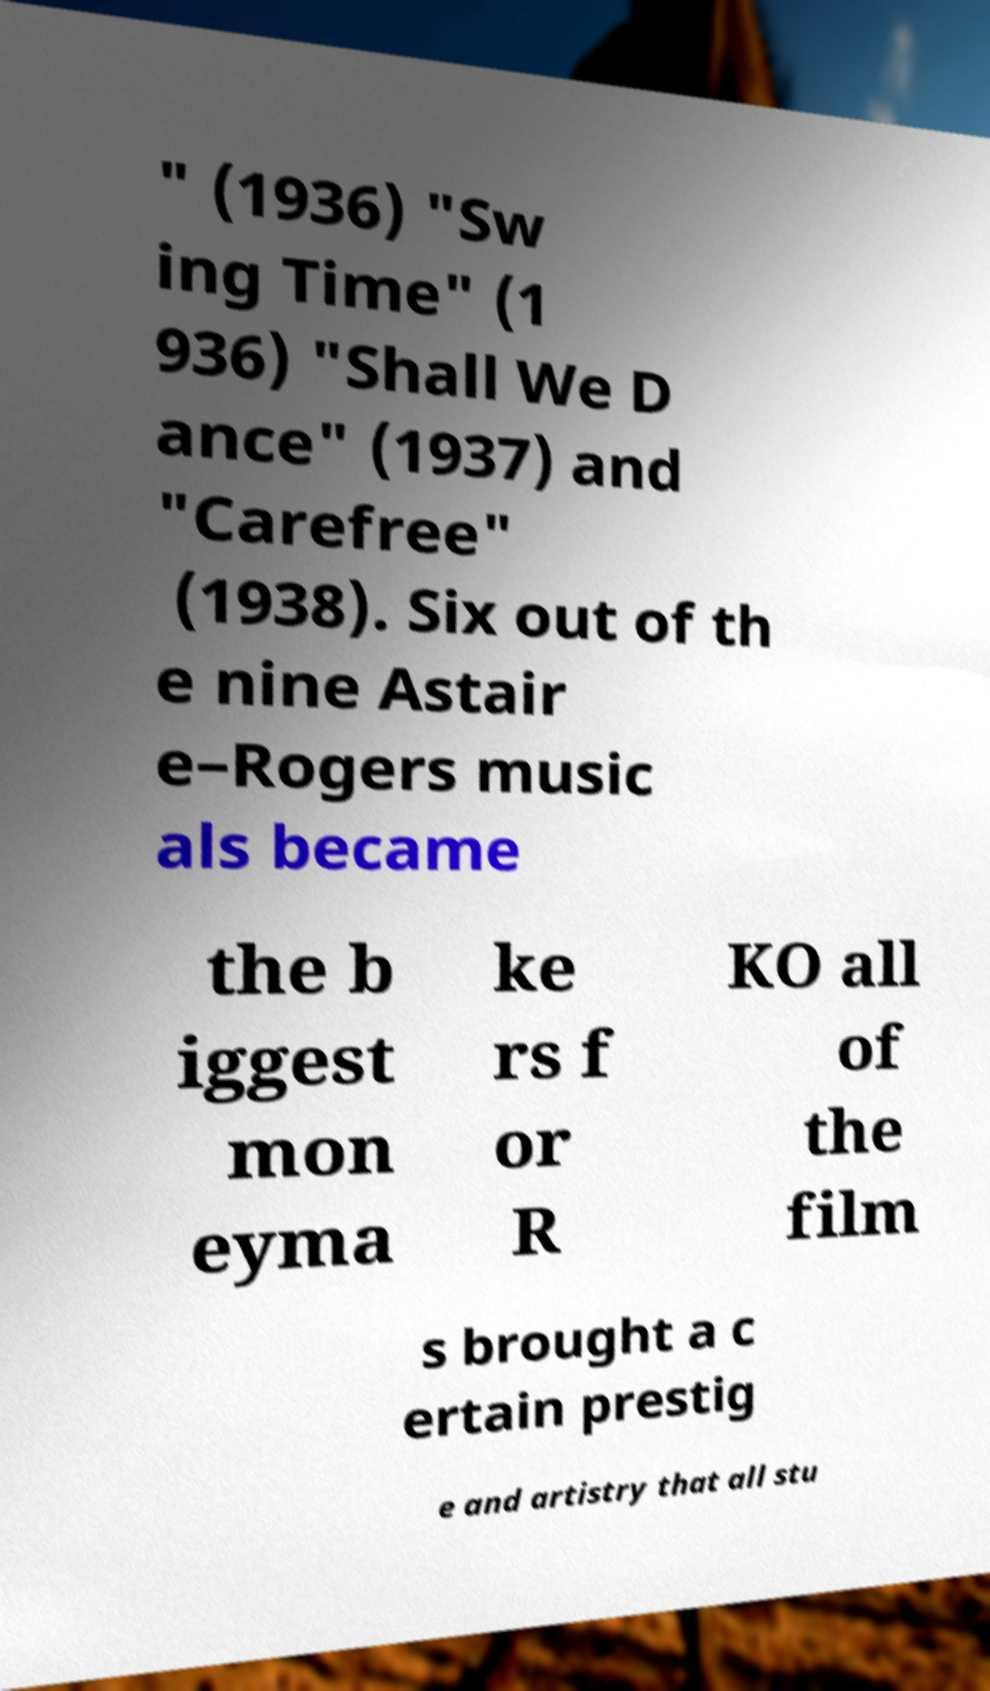Please identify and transcribe the text found in this image. " (1936) "Sw ing Time" (1 936) "Shall We D ance" (1937) and "Carefree" (1938). Six out of th e nine Astair e–Rogers music als became the b iggest mon eyma ke rs f or R KO all of the film s brought a c ertain prestig e and artistry that all stu 